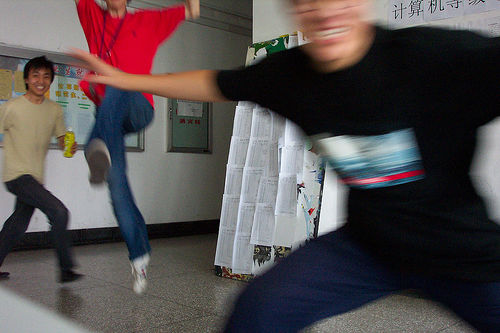Can you describe what's happening in this scene? It appears to be an indoor setting with three individuals engaged in playful activity. One person in a black shirt is blurred in the foreground, indicating rapid movement, while the person in red seems to be jumping or kicking midair, and the one in yellow is standing by, smiling. Why do you think someone took this photo? The photo could have been taken to capture a moment of fun and spontaneity among friends. It has a candid and dynamic feel, suggesting that the photographer wanted to preserve the memory of this lively interaction. 